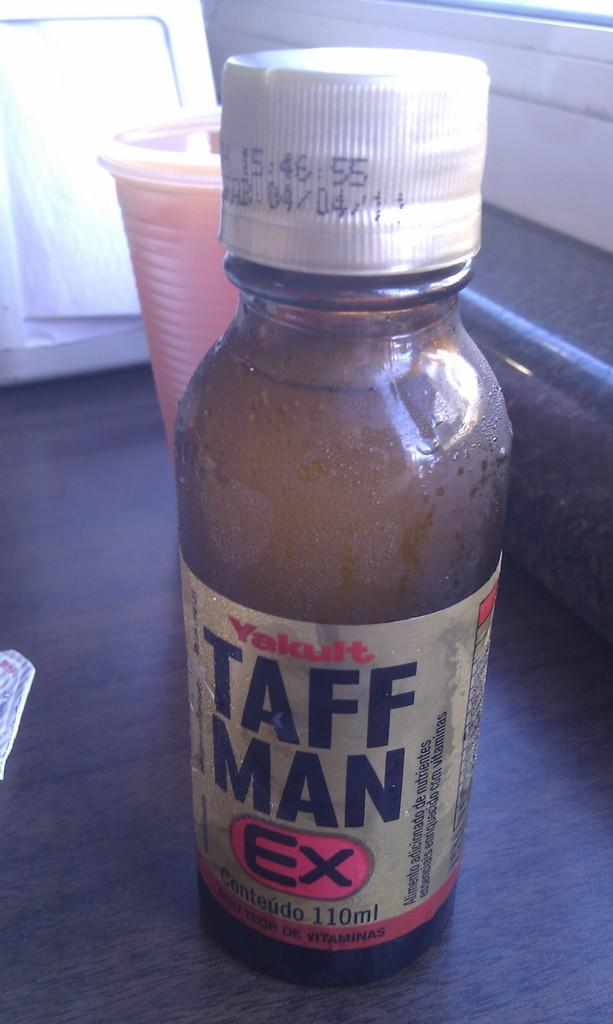Provide a one-sentence caption for the provided image. A bottle of Taff Man Ex contains 110 ml of liquid. 